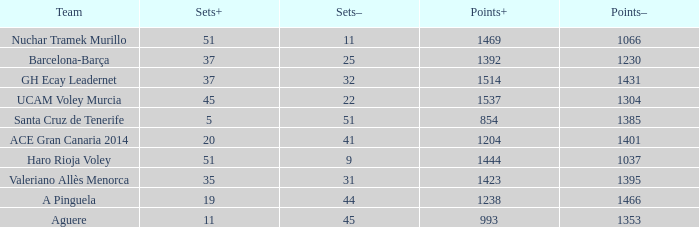What is the highest Points+ number when the Points- number is larger than 1385, a Sets+ number smaller than 37 and a Sets- number larger than 41? 1238.0. 